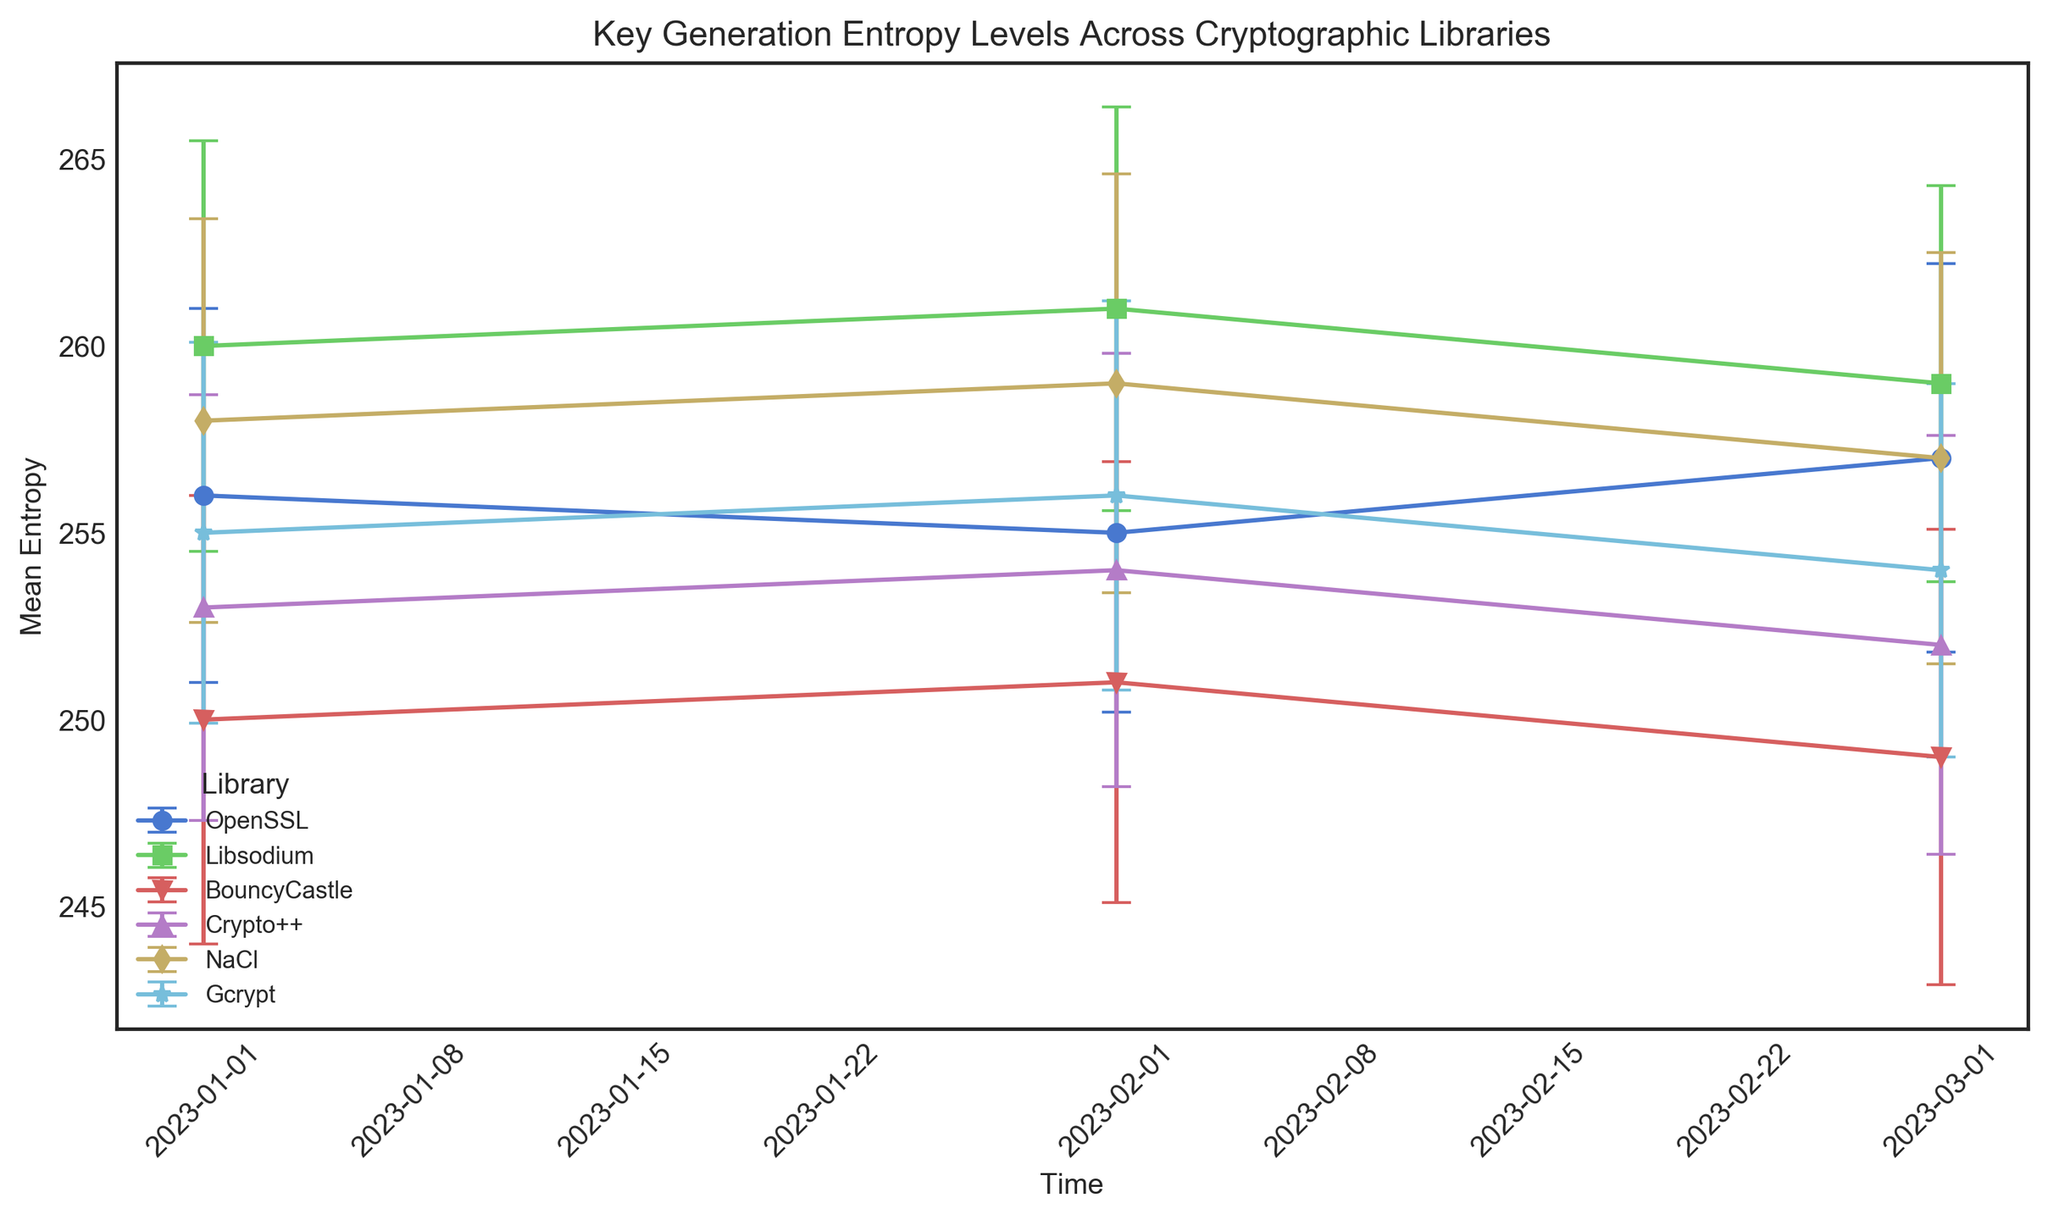What is the mean entropy level of OpenSSL in February 2023? Look at the error bars corresponding to OpenSSL for the given time frame (February 2023) to determine the mean entropy level.
Answer: 255 Which library has the highest mean entropy level in January 2023? Compare the mean entropy levels across all libraries for January 2023. Libsodium has the highest value at 260.
Answer: Libsodium Does any library show a decreasing trend in mean entropy from January 2023 to March 2023? Observe the slopes of the lines for each library over the time frame. BouncyCastle shows a consistent decrease in mean entropy.
Answer: BouncyCastle Which library exhibits the most variability in its entropy levels over the observed period? Compare the lengths of the error bars for each library; longer error bars indicate higher variability. BouncyCastle has the largest standard deviations (6 in Jan, 5.9 in Feb, and 6.1 in Mar).
Answer: BouncyCastle What is the difference in mean entropy between Libsodium and Crypto++ in March 2023? Subtract the mean entropy level of Crypto++ in March (252) from that of Libsodium in March (259).
Answer: 7 Which libraries maintain a mean entropy level above 250 in all three months? Review the mean values for each library across the specified months to ascertain which consistently stay above 250. OpenSSL, Libsodium, Crypto++, NaCl, and Gcrypt all maintain levels above 250.
Answer: OpenSSL, Libsodium, Crypto++, NaCl, Gcrypt Compare the trend in mean entropy levels between Gcrypt and NaCl from January to March 2023. Look at the lines representing Gcrypt and NaCl and see how they progress over the three months. Both Gcrypt and NaCl show minor fluctuations with Gcrypt slightly decreasing and NaCl showing a slight decrease after a rise in February.
Answer: Similar trend with minor fluctuations 